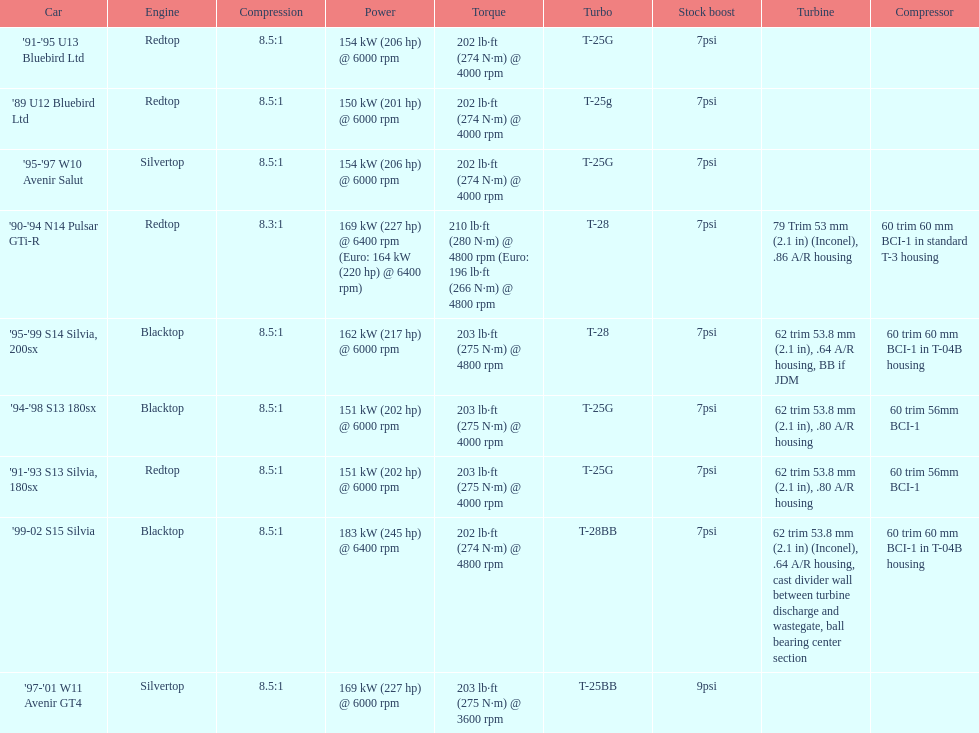Which car is the only one with more than 230 hp? '99-02 S15 Silvia. 